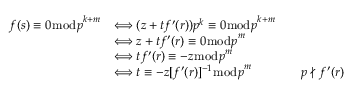Convert formula to latex. <formula><loc_0><loc_0><loc_500><loc_500>{ \begin{array} { r l r l } { f ( s ) \equiv 0 { \bmod { p } } ^ { k + m } } & { \Longleftrightarrow ( z + t f ^ { \prime } ( r ) ) p ^ { k } \equiv 0 { \bmod { p } } ^ { k + m } } \\ & { \Longleftrightarrow z + t f ^ { \prime } ( r ) \equiv 0 { \bmod { p } } ^ { m } } \\ & { \Longleftrightarrow t f ^ { \prime } ( r ) \equiv - z { \bmod { p } } ^ { m } } \\ & { \Longleftrightarrow t \equiv - z [ f ^ { \prime } ( r ) ] ^ { - 1 } { \bmod { p } } ^ { m } } & & { p \nmid f ^ { \prime } ( r ) } \end{array} }</formula> 